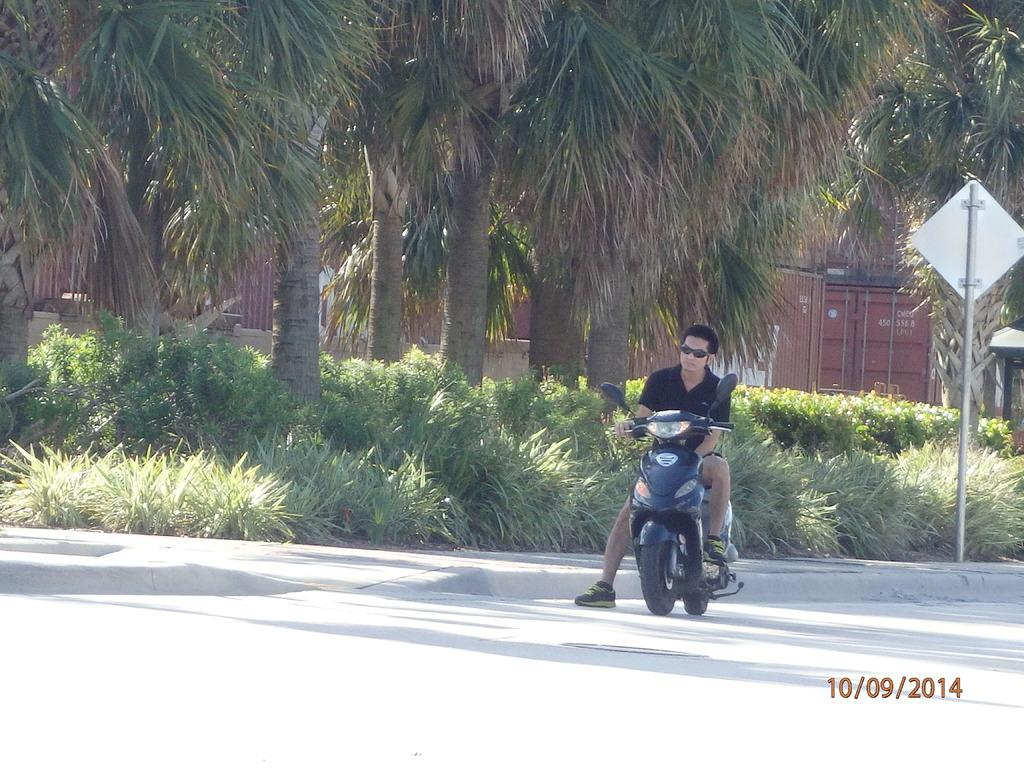What is the man in the image doing? The man is riding a motorbike in the image. Where is the man riding the motorbike? The man is on the road. What can be seen on the right side of the image? There is a board and pole on the right side of the image. What type of vegetation is visible in the image? There are trees and plants visible in the image. What objects are present in the image that might be used for storage or transportation? There are containers in the image. What type of jeans is the man wearing in the image? There is no information about the man's clothing in the image, so we cannot determine if he is wearing jeans or any other type of clothing. 